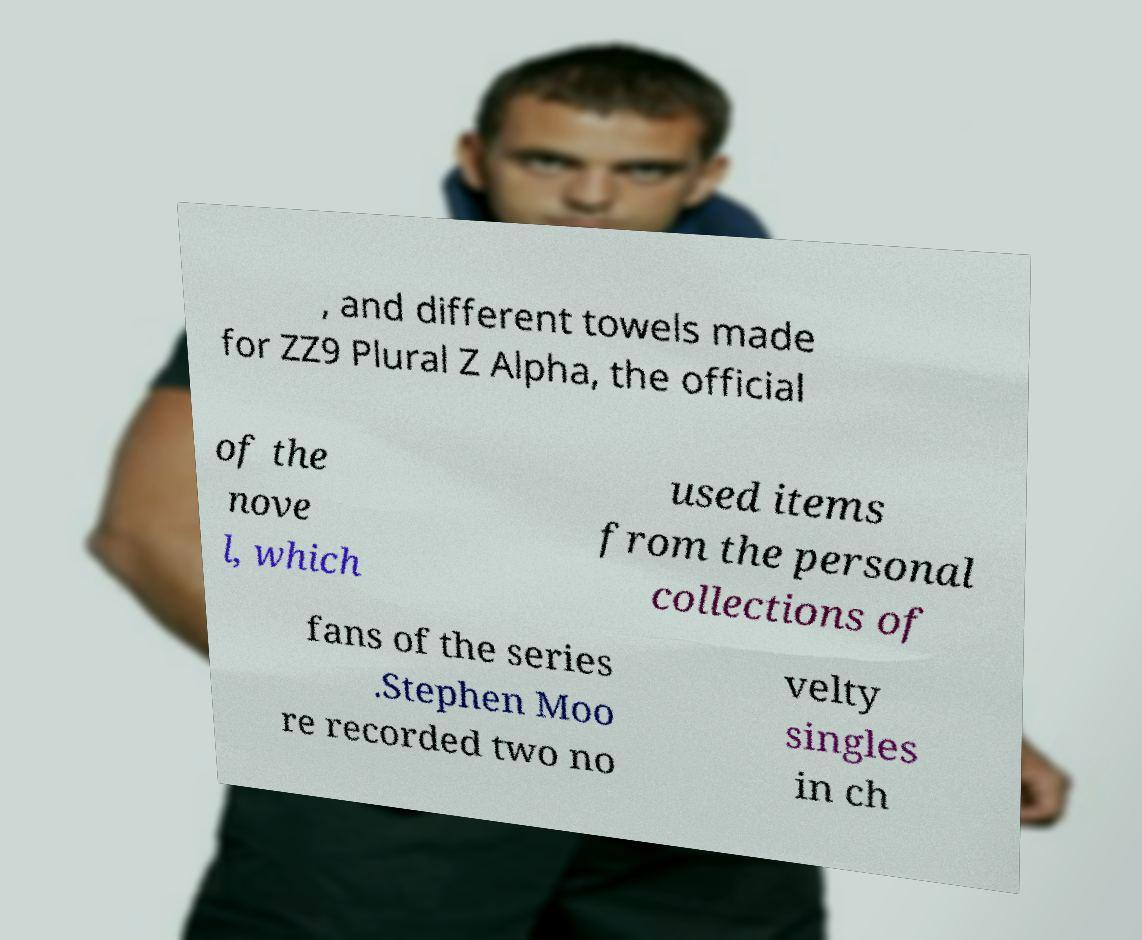For documentation purposes, I need the text within this image transcribed. Could you provide that? , and different towels made for ZZ9 Plural Z Alpha, the official of the nove l, which used items from the personal collections of fans of the series .Stephen Moo re recorded two no velty singles in ch 